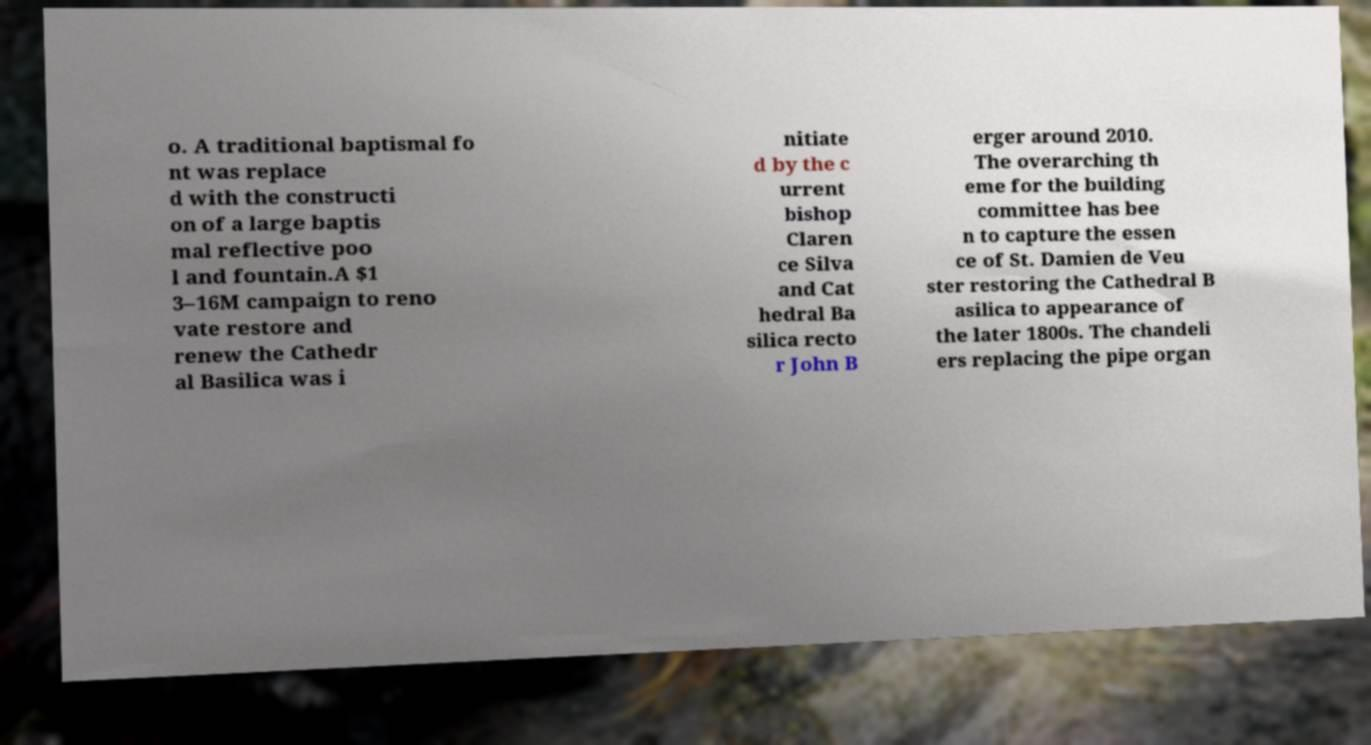Please read and relay the text visible in this image. What does it say? o. A traditional baptismal fo nt was replace d with the constructi on of a large baptis mal reflective poo l and fountain.A $1 3–16M campaign to reno vate restore and renew the Cathedr al Basilica was i nitiate d by the c urrent bishop Claren ce Silva and Cat hedral Ba silica recto r John B erger around 2010. The overarching th eme for the building committee has bee n to capture the essen ce of St. Damien de Veu ster restoring the Cathedral B asilica to appearance of the later 1800s. The chandeli ers replacing the pipe organ 